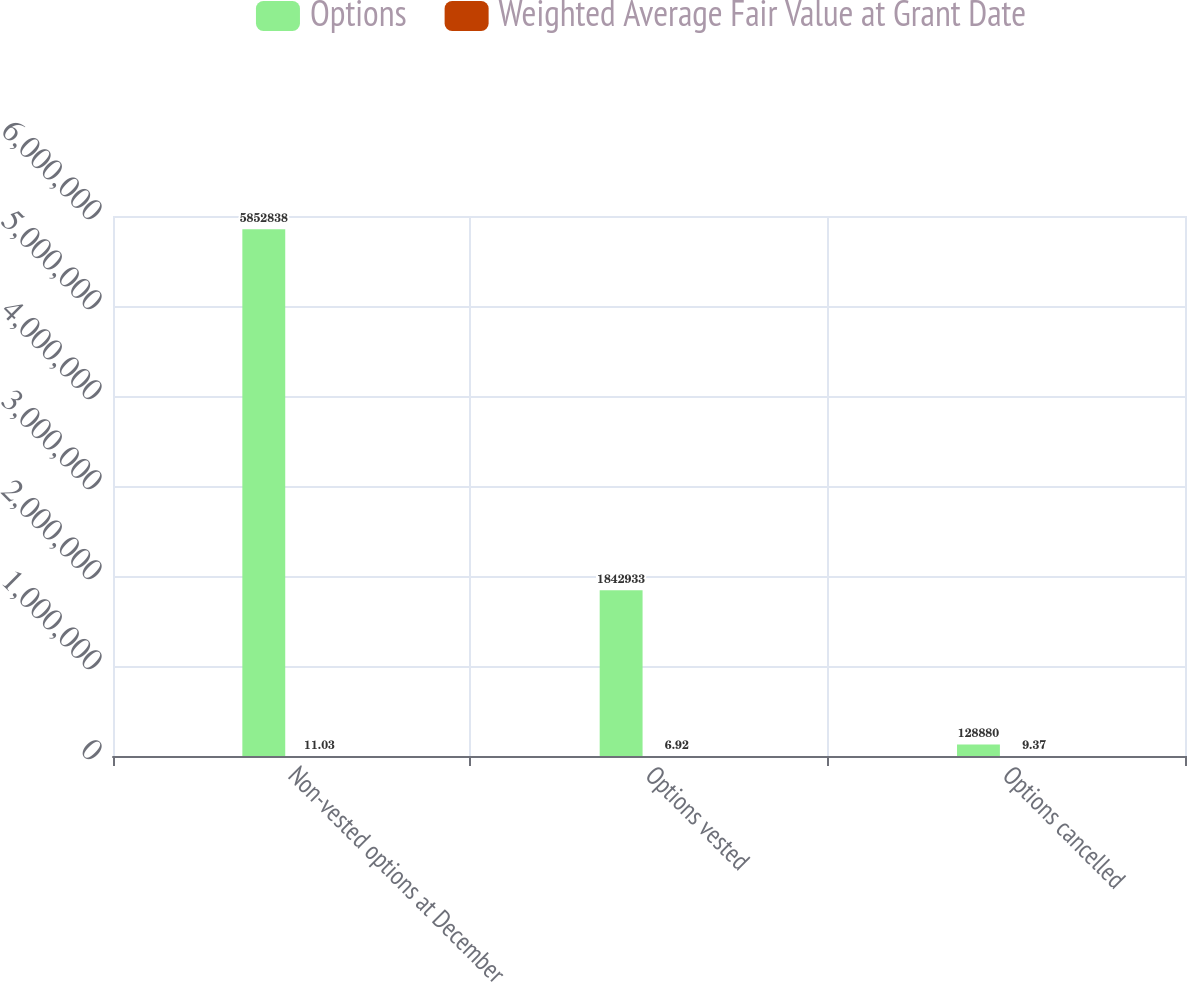Convert chart. <chart><loc_0><loc_0><loc_500><loc_500><stacked_bar_chart><ecel><fcel>Non-vested options at December<fcel>Options vested<fcel>Options cancelled<nl><fcel>Options<fcel>5.85284e+06<fcel>1.84293e+06<fcel>128880<nl><fcel>Weighted Average Fair Value at Grant Date<fcel>11.03<fcel>6.92<fcel>9.37<nl></chart> 